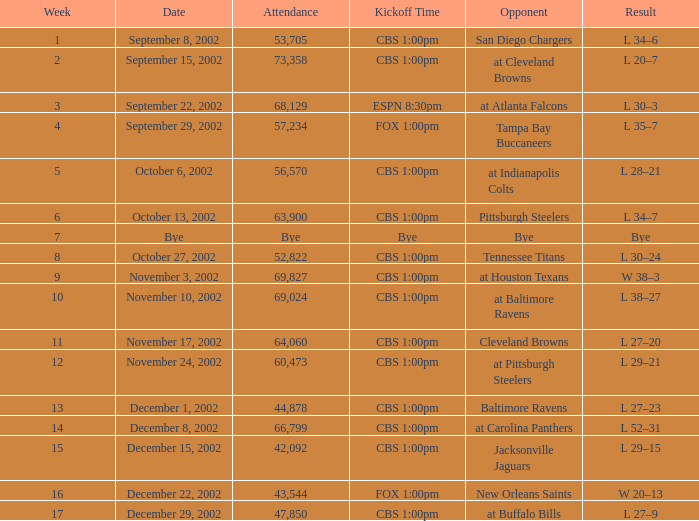What week number was the kickoff time cbs 1:00pm, with 60,473 people in attendance? 1.0. 